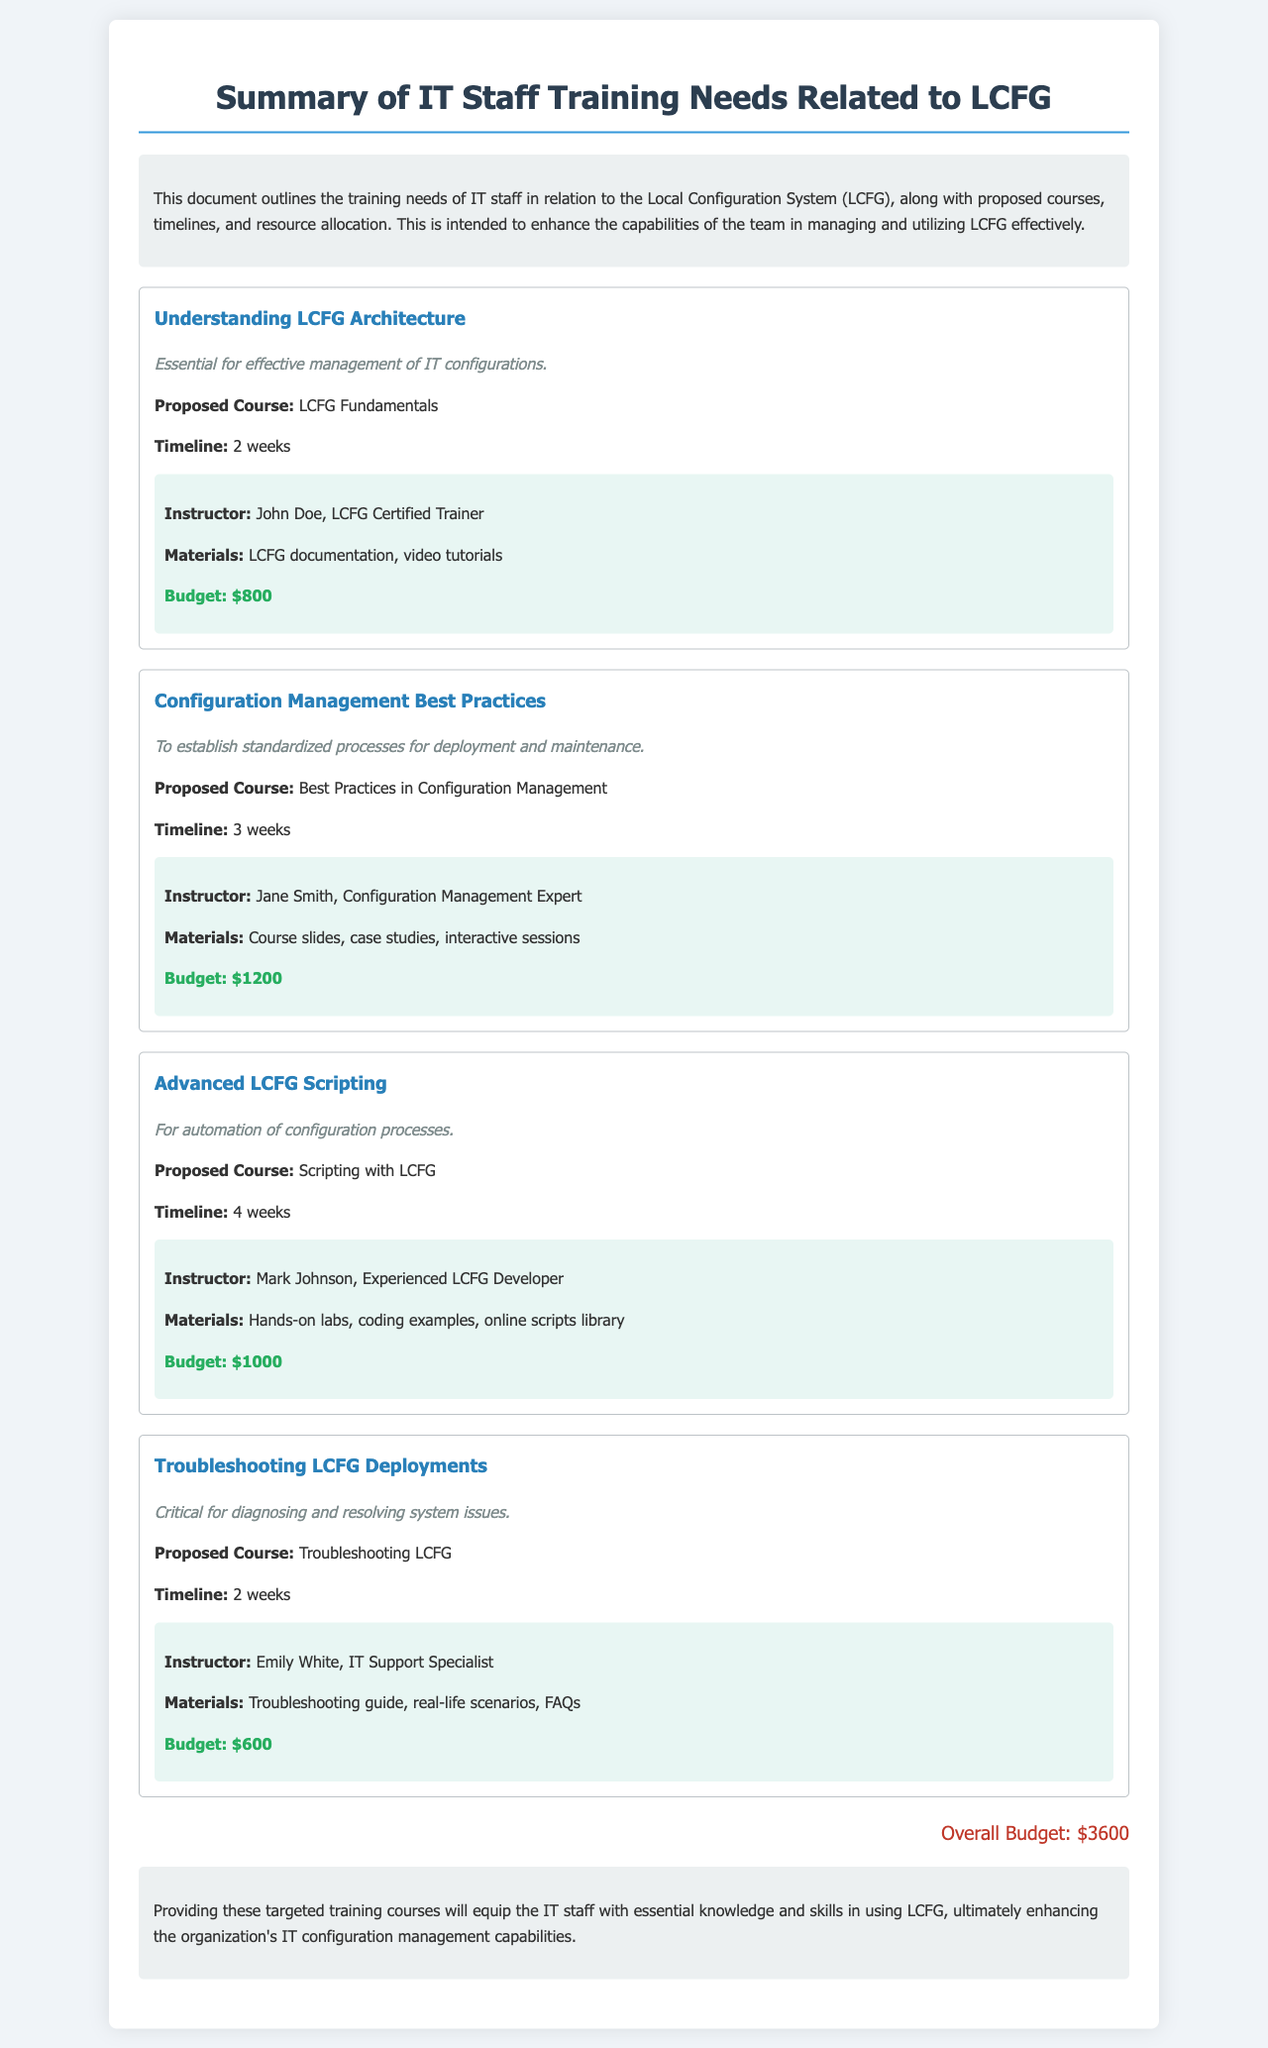What is the proposed course for understanding LCFG architecture? The document states "Proposed Course: LCFG Fundamentals" under the section for Understanding LCFG Architecture.
Answer: LCFG Fundamentals How long is the timeline for the Configuration Management Best Practices course? The timeline is provided as "3 weeks" in the section for Configuration Management Best Practices.
Answer: 3 weeks Who is the instructor for the Advanced LCFG Scripting course? The document lists "Instructor: Mark Johnson, Experienced LCFG Developer" for the Advanced LCFG Scripting course.
Answer: Mark Johnson What is the budget for Troubleshooting LCFG Deployments? The budget stated in the document for Troubleshooting LCFG is "$600."
Answer: $600 What is the overall budget for the training programs described? The overall budget is explicitly mentioned as "Overall Budget: $3600" in the conclusion section of the document.
Answer: $3600 Which course focuses on diagnosing and resolving system issues? The document highlights "Troubleshooting LCFG" as the course focused on diagnosing and resolving system issues.
Answer: Troubleshooting LCFG What is the primary importance listed for learning about Configuration Management Best Practices? The document indicates that it is "To establish standardized processes for deployment and maintenance."
Answer: Standardized processes What types of materials are mentioned for the LCFG Fundamentals course? The materials listed for the LCFG Fundamentals course include "LCFG documentation, video tutorials."
Answer: LCFG documentation, video tutorials How many training needs are outlined in the document? The document contains four training needs related to LCFG.
Answer: Four 